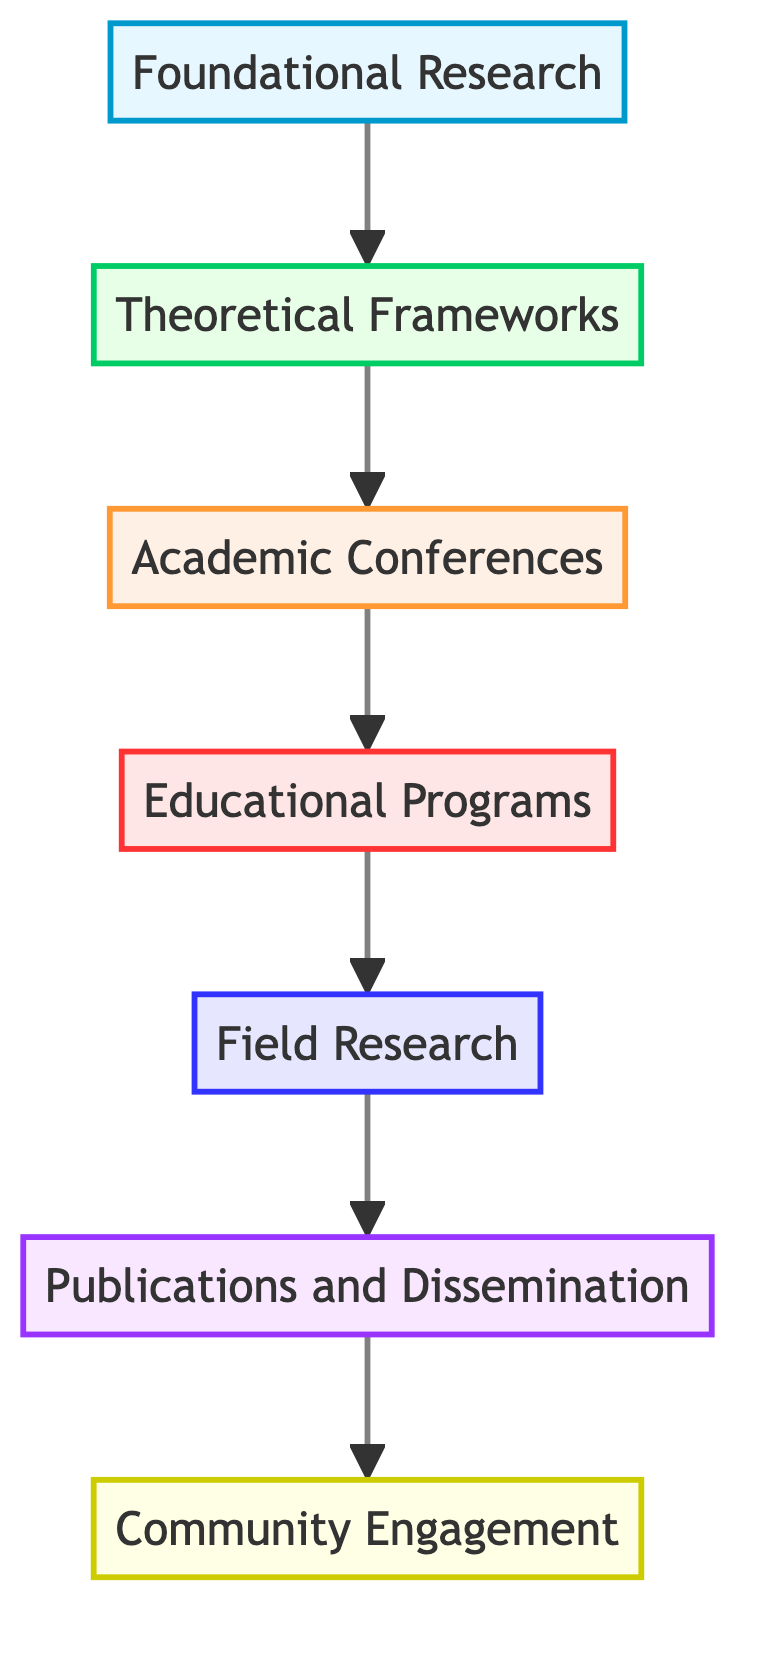What is the highest level in the diagram? The diagram presents a hierarchical flow with seven levels. The highest level, which is the last node in the upward flow, is "Community Engagement."
Answer: Community Engagement How many nodes are there in the diagram? The diagram includes a total of seven distinct levels or nodes arranged vertically. Each level represents a different stage in interreligious dialogue initiatives.
Answer: Seven Which stage comes directly after "Academic Conferences"? According to the sequential arrangement of the diagram, the stage that follows "Academic Conferences" is "Educational Programs."
Answer: Educational Programs What is the relationship between "Foundational Research" and "Theoretical Frameworks"? "Foundational Research" is the first stage and leads directly to "Theoretical Frameworks" in the flow of the diagram, indicating that foundational research informs theoretical frameworks.
Answer: Foundational Research informs Theoretical Frameworks What is the focus of "Field Research"? The "Field Research" stage emphasizes observing and participating in actual interreligious dialogue initiatives, in conjunction with religious communities.
Answer: Observing initiatives How does "Publications and Dissemination" relate to "Educational Programs"? In the flow of the diagram, "Publications and Dissemination" is positioned after "Field Research," which in turn follows "Educational Programs," indicating that the findings from educational programs can inform subsequent publishing efforts.
Answer: Findings inform publishing What type of engagement is emphasized at the top of the diagram? The top level, "Community Engagement," emphasizes active involvement with a wider audience through discussions and collaborative initiatives between different religious communities.
Answer: Active involvement Which stage involves the development of curricula? The stage where the development of educational programs and curricula occurs is described as "Educational Programs."
Answer: Educational Programs What is the significance of "Academic Conferences" in the flow? "Academic Conferences" serves as a platform for discussing interreligious dialogue initiatives and sharing findings from previous research, playing a crucial role in connecting scholars.
Answer: Discussing initiatives 